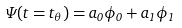<formula> <loc_0><loc_0><loc_500><loc_500>\Psi ( t = t _ { \theta } ) = a _ { 0 } \phi _ { 0 } + a _ { 1 } \phi _ { 1 }</formula> 